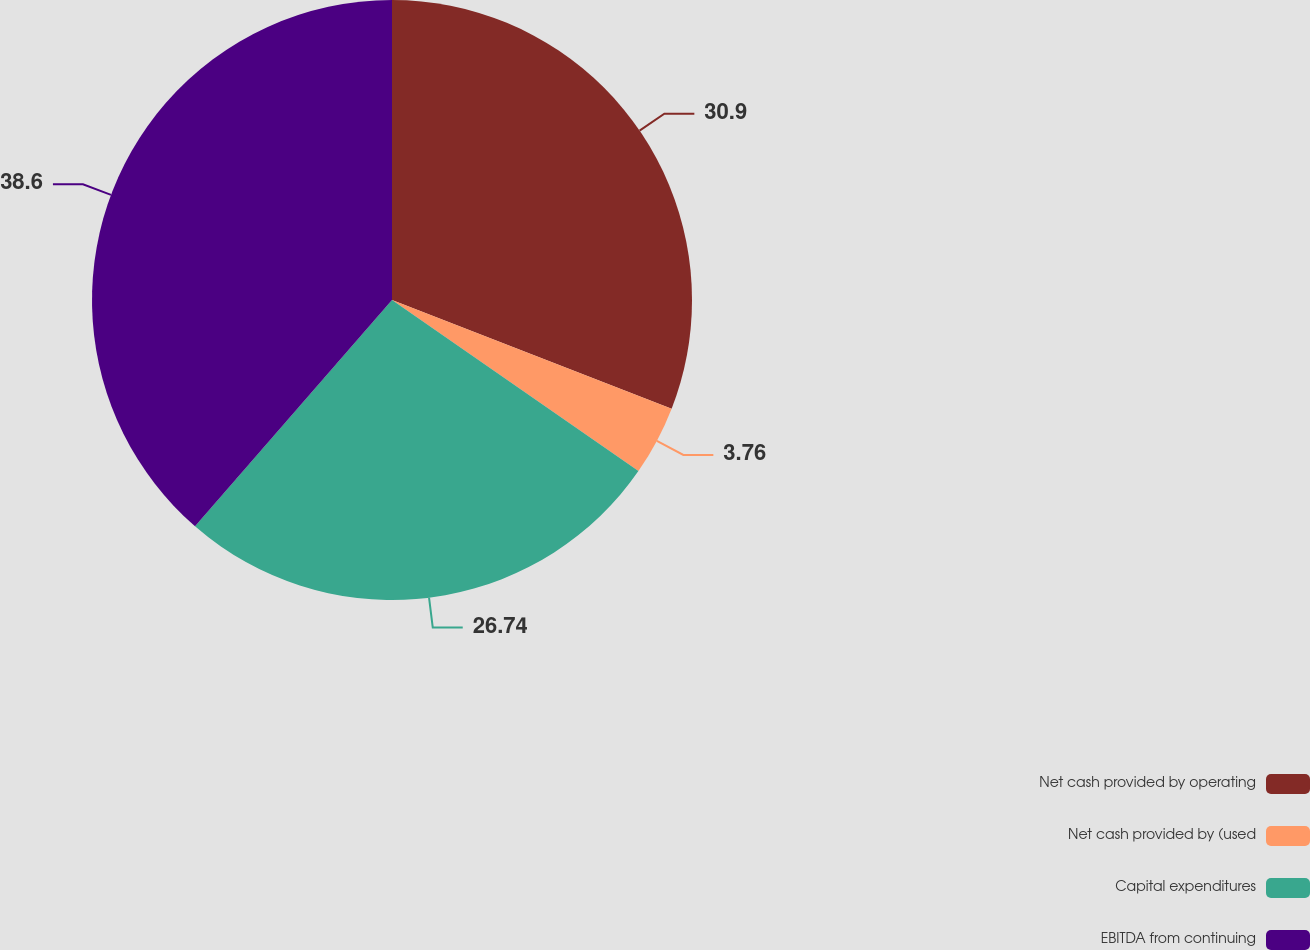<chart> <loc_0><loc_0><loc_500><loc_500><pie_chart><fcel>Net cash provided by operating<fcel>Net cash provided by (used<fcel>Capital expenditures<fcel>EBITDA from continuing<nl><fcel>30.9%<fcel>3.76%<fcel>26.74%<fcel>38.6%<nl></chart> 